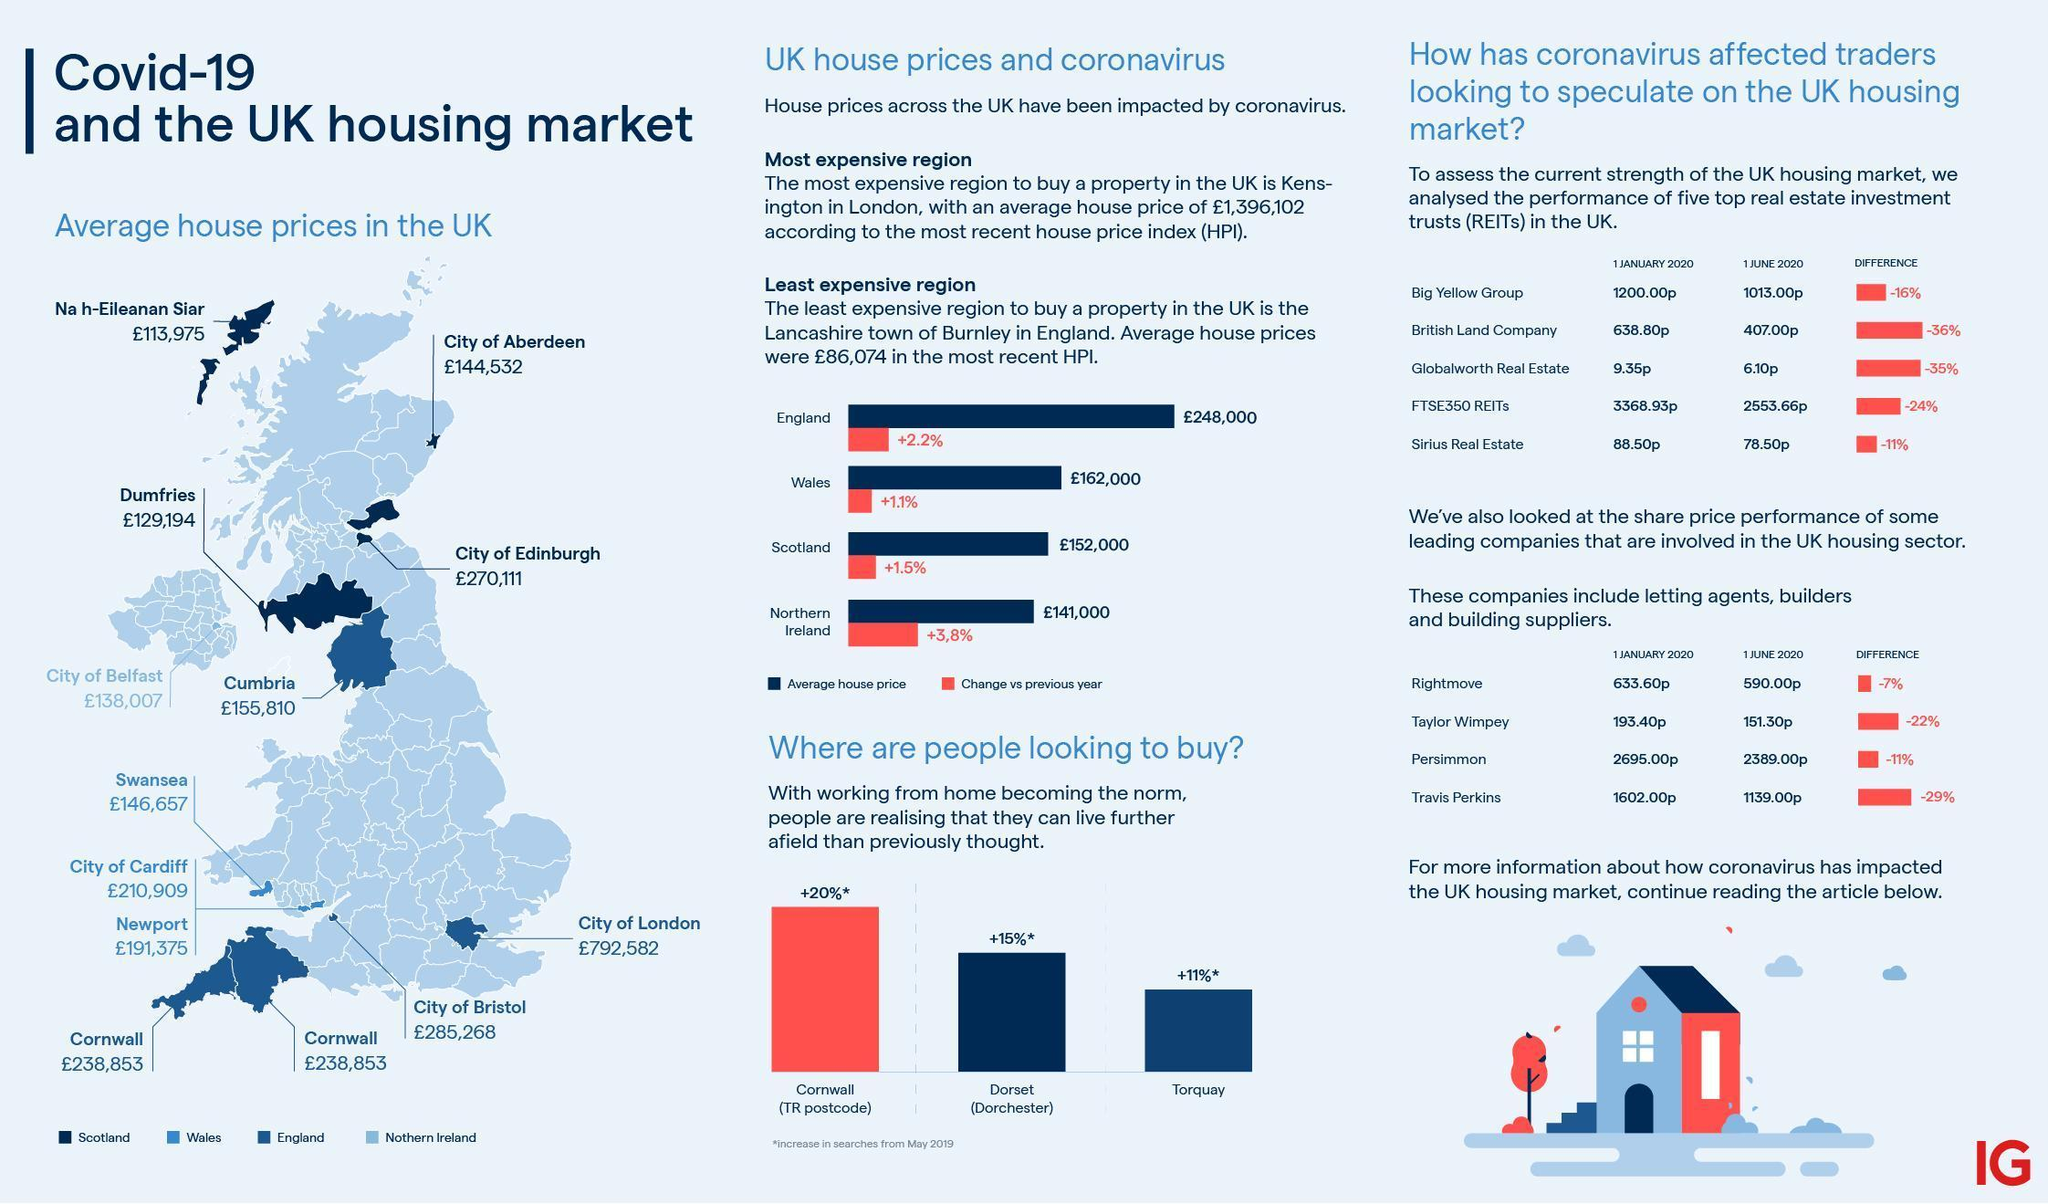What is the average house price (in pounds) in the City of Bristol?
Answer the question with a short phrase. 285,268 What is the average house price (in pounds) in the City of London? 792,582 